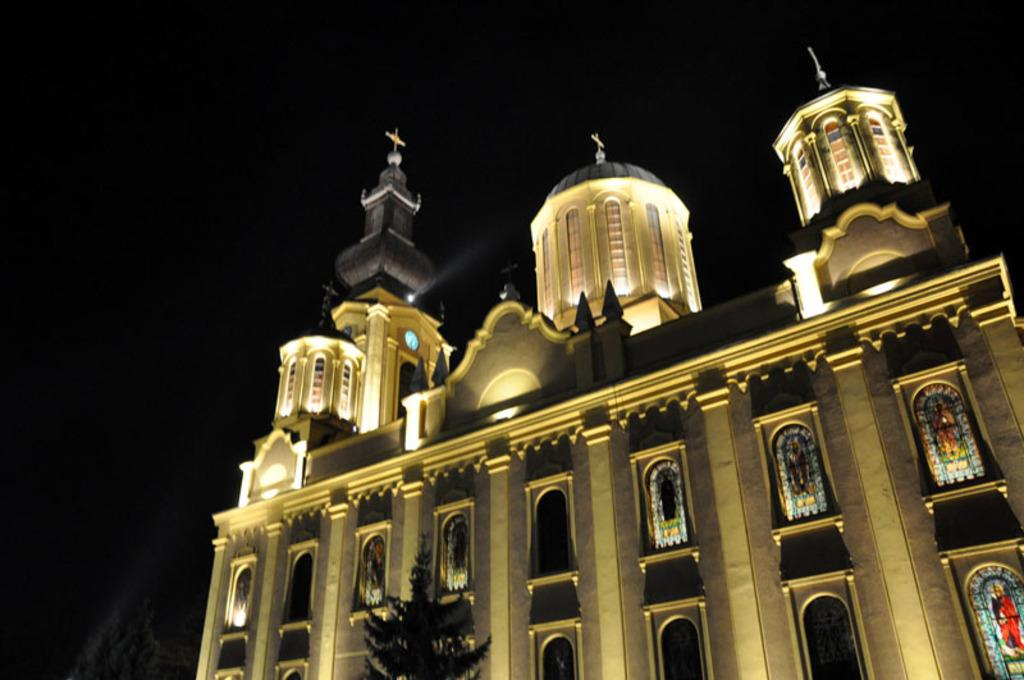What is the main subject of the image? The main subject of the image is a building. Can you describe the color scheme of the building? The building has a cream and brown color scheme. What can be seen in the background of the image? The background of the image is dark. What type of plantation is visible in the image? There is no plantation present in the image; it features a building with a cream and brown color scheme against a dark background. What statement can be made about the presence of a pump in the image? There is no pump visible in the image. 